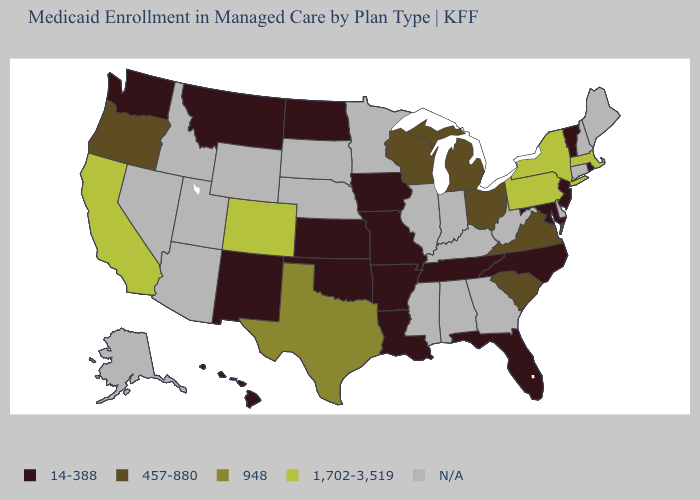Among the states that border Wyoming , which have the highest value?
Write a very short answer. Colorado. Name the states that have a value in the range 1,702-3,519?
Keep it brief. California, Colorado, Massachusetts, New York, Pennsylvania. Name the states that have a value in the range 14-388?
Quick response, please. Arkansas, Florida, Hawaii, Iowa, Kansas, Louisiana, Maryland, Missouri, Montana, New Jersey, New Mexico, North Carolina, North Dakota, Oklahoma, Rhode Island, Tennessee, Vermont, Washington. Is the legend a continuous bar?
Write a very short answer. No. Which states have the highest value in the USA?
Quick response, please. California, Colorado, Massachusetts, New York, Pennsylvania. Is the legend a continuous bar?
Quick response, please. No. Does Washington have the highest value in the West?
Give a very brief answer. No. What is the lowest value in the West?
Quick response, please. 14-388. Does the first symbol in the legend represent the smallest category?
Answer briefly. Yes. What is the highest value in the Northeast ?
Concise answer only. 1,702-3,519. Does Kansas have the lowest value in the USA?
Be succinct. Yes. Name the states that have a value in the range 948?
Quick response, please. Texas. Name the states that have a value in the range 1,702-3,519?
Concise answer only. California, Colorado, Massachusetts, New York, Pennsylvania. What is the highest value in the USA?
Be succinct. 1,702-3,519. 